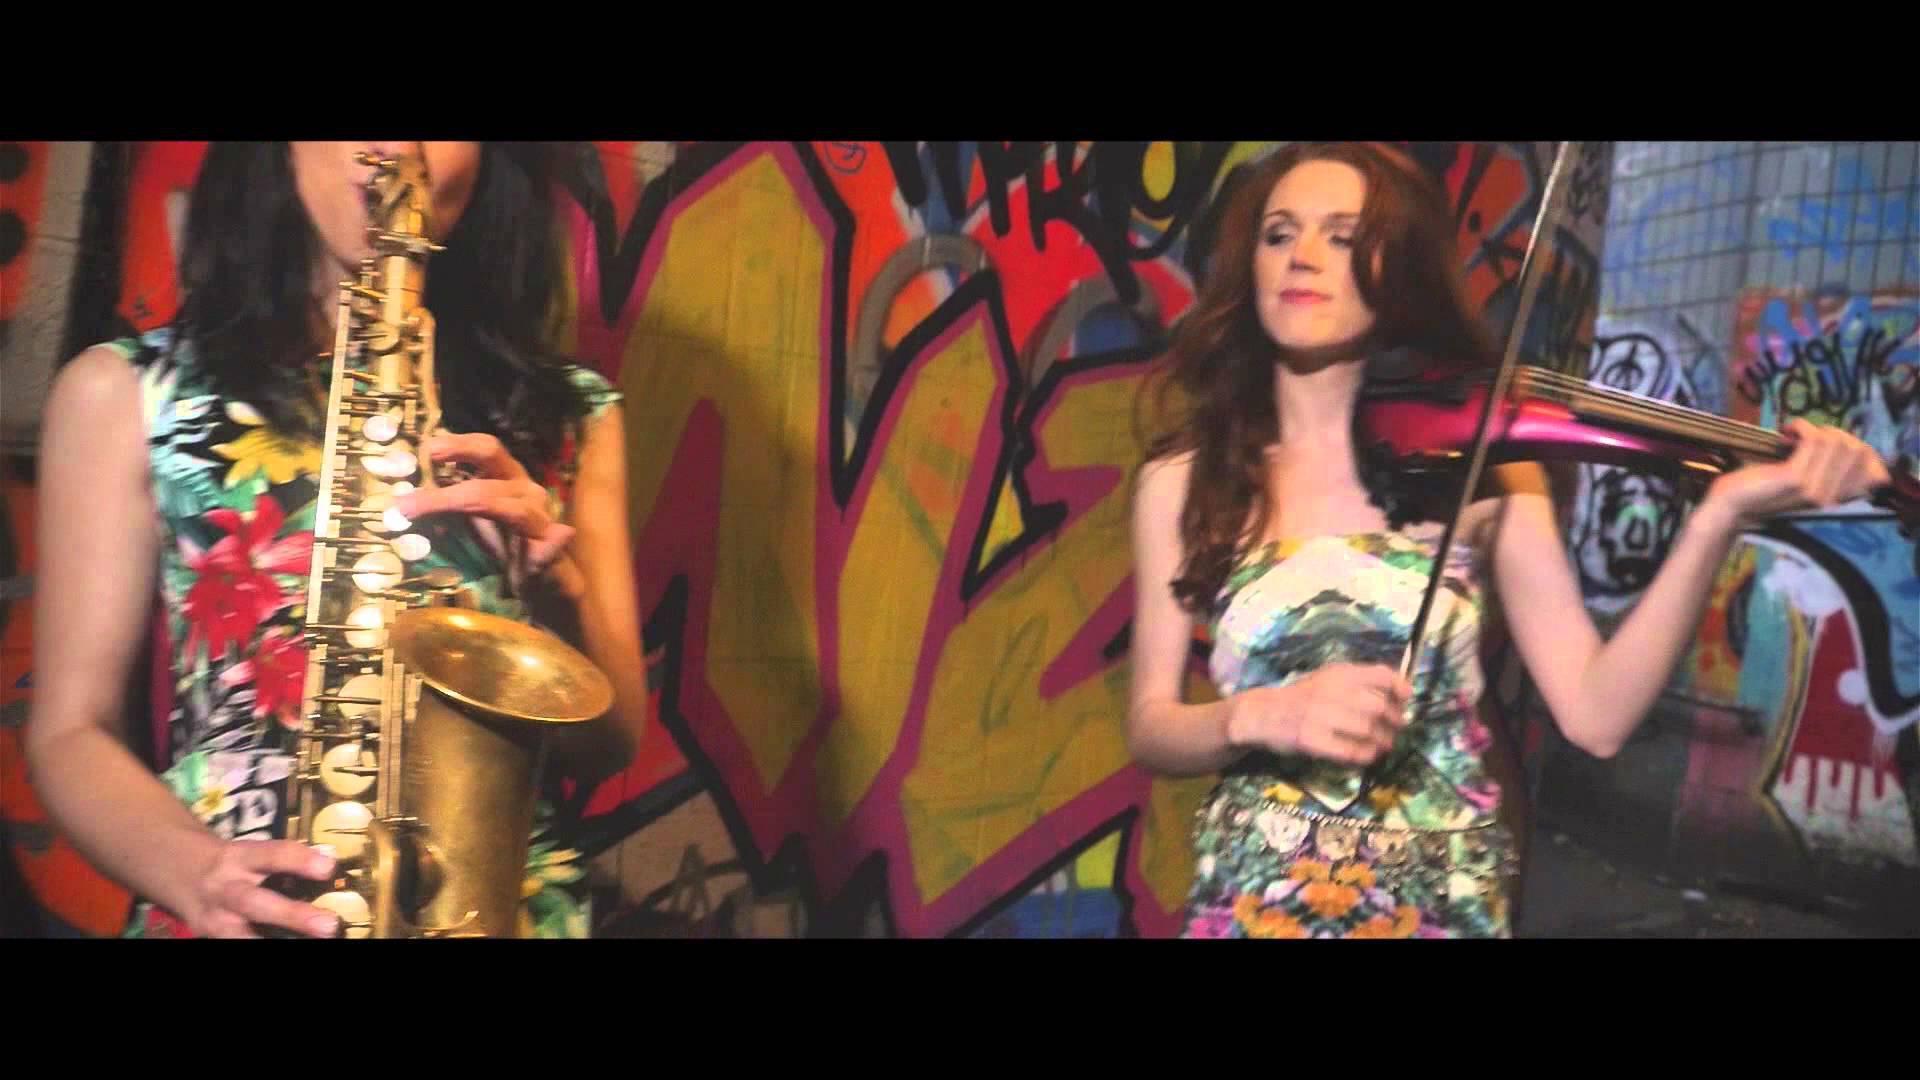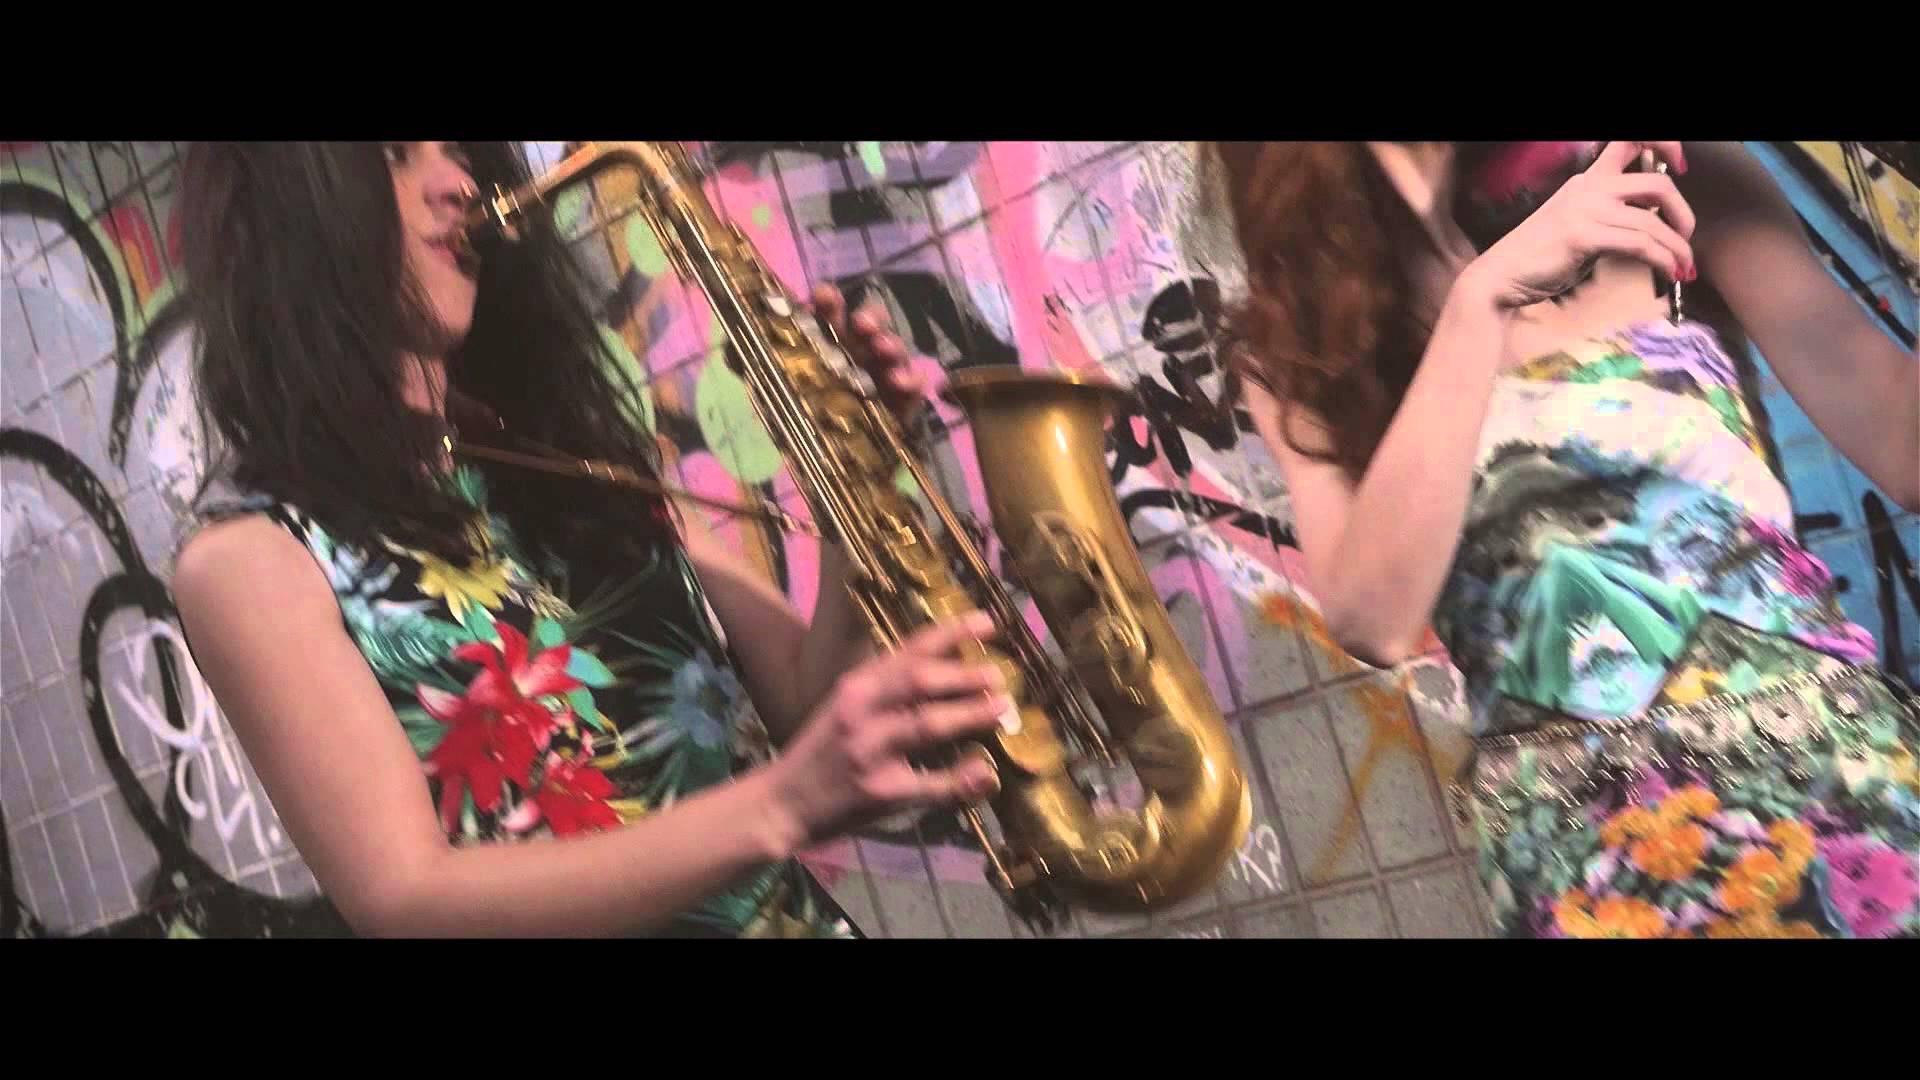The first image is the image on the left, the second image is the image on the right. For the images shown, is this caption "At least one woman appears to be actively playing a saxophone." true? Answer yes or no. Yes. The first image is the image on the left, the second image is the image on the right. Considering the images on both sides, is "There are no more than three people in the pair of images." valid? Answer yes or no. No. 